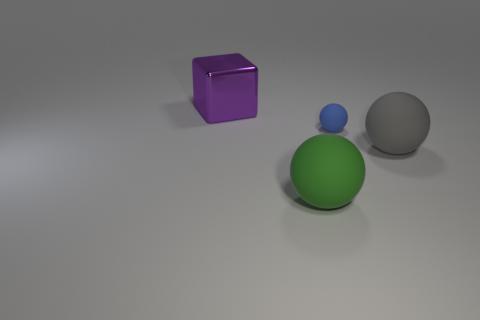Add 3 small purple rubber cylinders. How many objects exist? 7 Subtract all spheres. How many objects are left? 1 Subtract 0 yellow balls. How many objects are left? 4 Subtract all large purple matte cylinders. Subtract all tiny blue things. How many objects are left? 3 Add 3 purple shiny objects. How many purple shiny objects are left? 4 Add 3 green rubber balls. How many green rubber balls exist? 4 